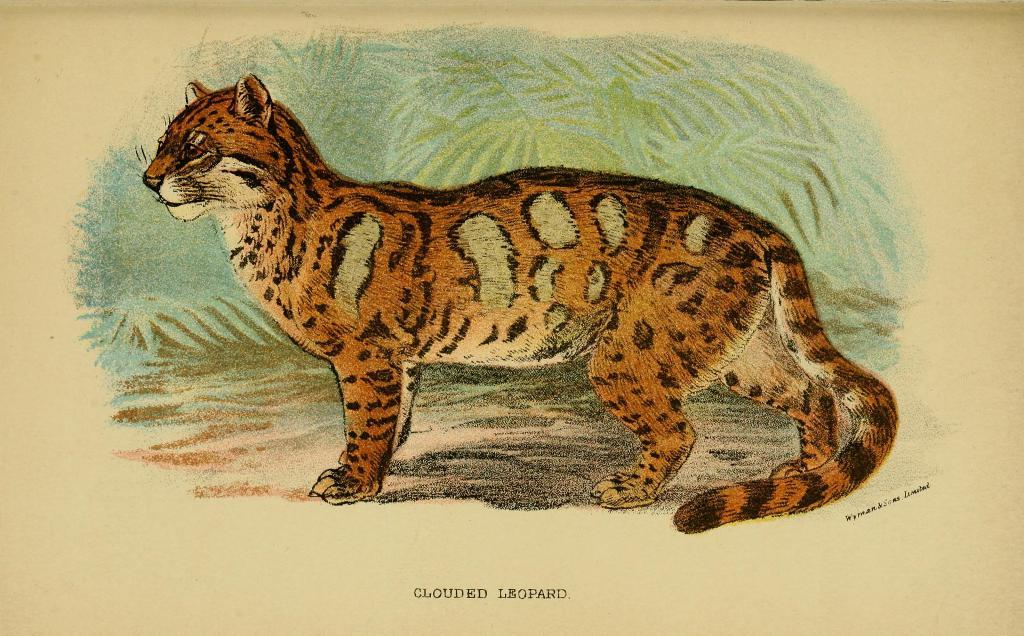What is the main subject of the image? There is an animal depicted in the image. What type of artwork is the image? The image is a painting. Is there any text present in the image? Yes, there is text at the bottom of the image. What type of apparel is the animal wearing in the image? There is no apparel present on the animal in the image, as it is a painting and not a photograph. 